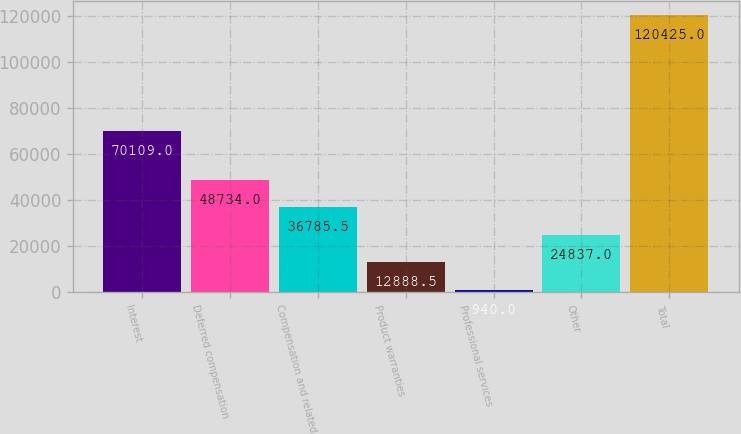Convert chart to OTSL. <chart><loc_0><loc_0><loc_500><loc_500><bar_chart><fcel>Interest<fcel>Deferred compensation<fcel>Compensation and related<fcel>Product warranties<fcel>Professional services<fcel>Other<fcel>Total<nl><fcel>70109<fcel>48734<fcel>36785.5<fcel>12888.5<fcel>940<fcel>24837<fcel>120425<nl></chart> 